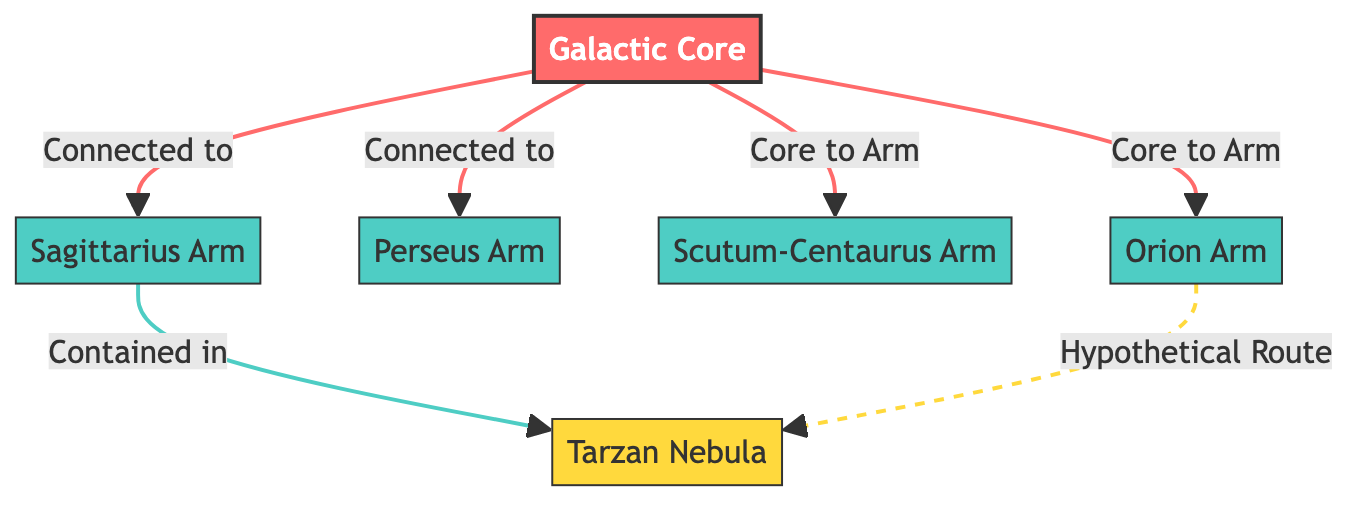What is the main component at the center of the Milky Way? The diagram shows "Galactic Core" as the central component labeled as node 1. This is often considered the heart of the galaxy.
Answer: Galactic Core How many spiral arms are shown in the diagram? The diagram displays four spiral arms: Sagittarius Arm, Perseus Arm, Scutum-Centaurus Arm, and Orion Arm. Counting these yields a total of four.
Answer: 4 Which nebula is contained within a spiral arm? The diagram indicates that the "Tarzan Nebula" is contained within the "Sagittarius Arm." This relationship is specified by the directional arrow connecting the two nodes.
Answer: Tarzan Nebula What is the relationship between the Galactic Core and the Orion Arm? The diagram illustrates an arrow indicating that the Galactic Core is directly connected to the Orion Arm. This means they are related in the structure of the galaxy.
Answer: Connected Which arm does the Tarzan Nebula hypothetically connect to? The diagram suggests a dashed line indicating a hypothetical route from the Orion Arm to the Tarzan Nebula. This implies a potential but unconfirmed connection.
Answer: Orion Arm What color represents the Galactic Core in the diagram? The Galactic Core is represented in red, which is defined in the styling of the diagram where the core component is given the fill color #FF6B6B.
Answer: Red What is the visual representation of the Scutum-Centaurus Arm? The Scutum-Centaurus Arm is illustrated as a green arm in the diagram, specifically styled with a fill color of #4ECDC4.
Answer: Green Which arm contains the Tarzan Nebula? The diagram states that the "Sagittarius Arm" contains the Tarzan Nebula, establishing a clear connection between these two components.
Answer: Sagittarius Arm What type of line indicates the hypothetical route to the Tarzan Nebula? The line linking to the Tarzan Nebula is styled as a dashed line. This visual distinction implies that it represents a hypothetical, rather than confirmed, connection.
Answer: Dashed line 